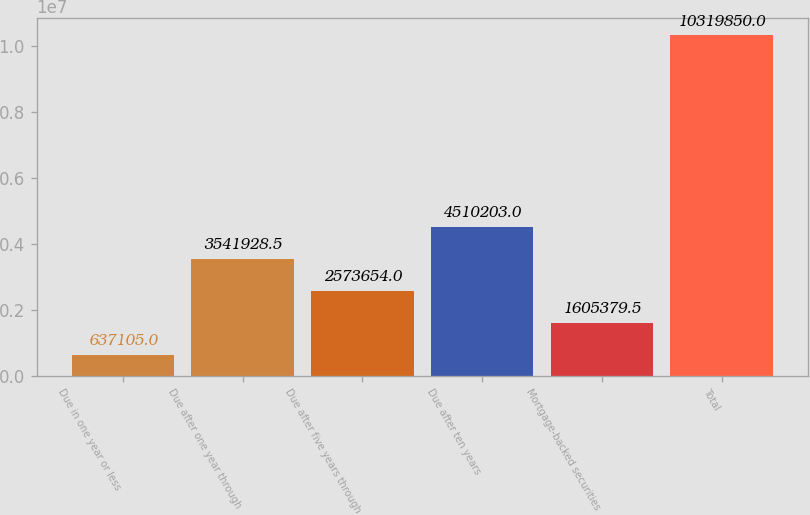Convert chart to OTSL. <chart><loc_0><loc_0><loc_500><loc_500><bar_chart><fcel>Due in one year or less<fcel>Due after one year through<fcel>Due after five years through<fcel>Due after ten years<fcel>Mortgage-backed securities<fcel>Total<nl><fcel>637105<fcel>3.54193e+06<fcel>2.57365e+06<fcel>4.5102e+06<fcel>1.60538e+06<fcel>1.03198e+07<nl></chart> 